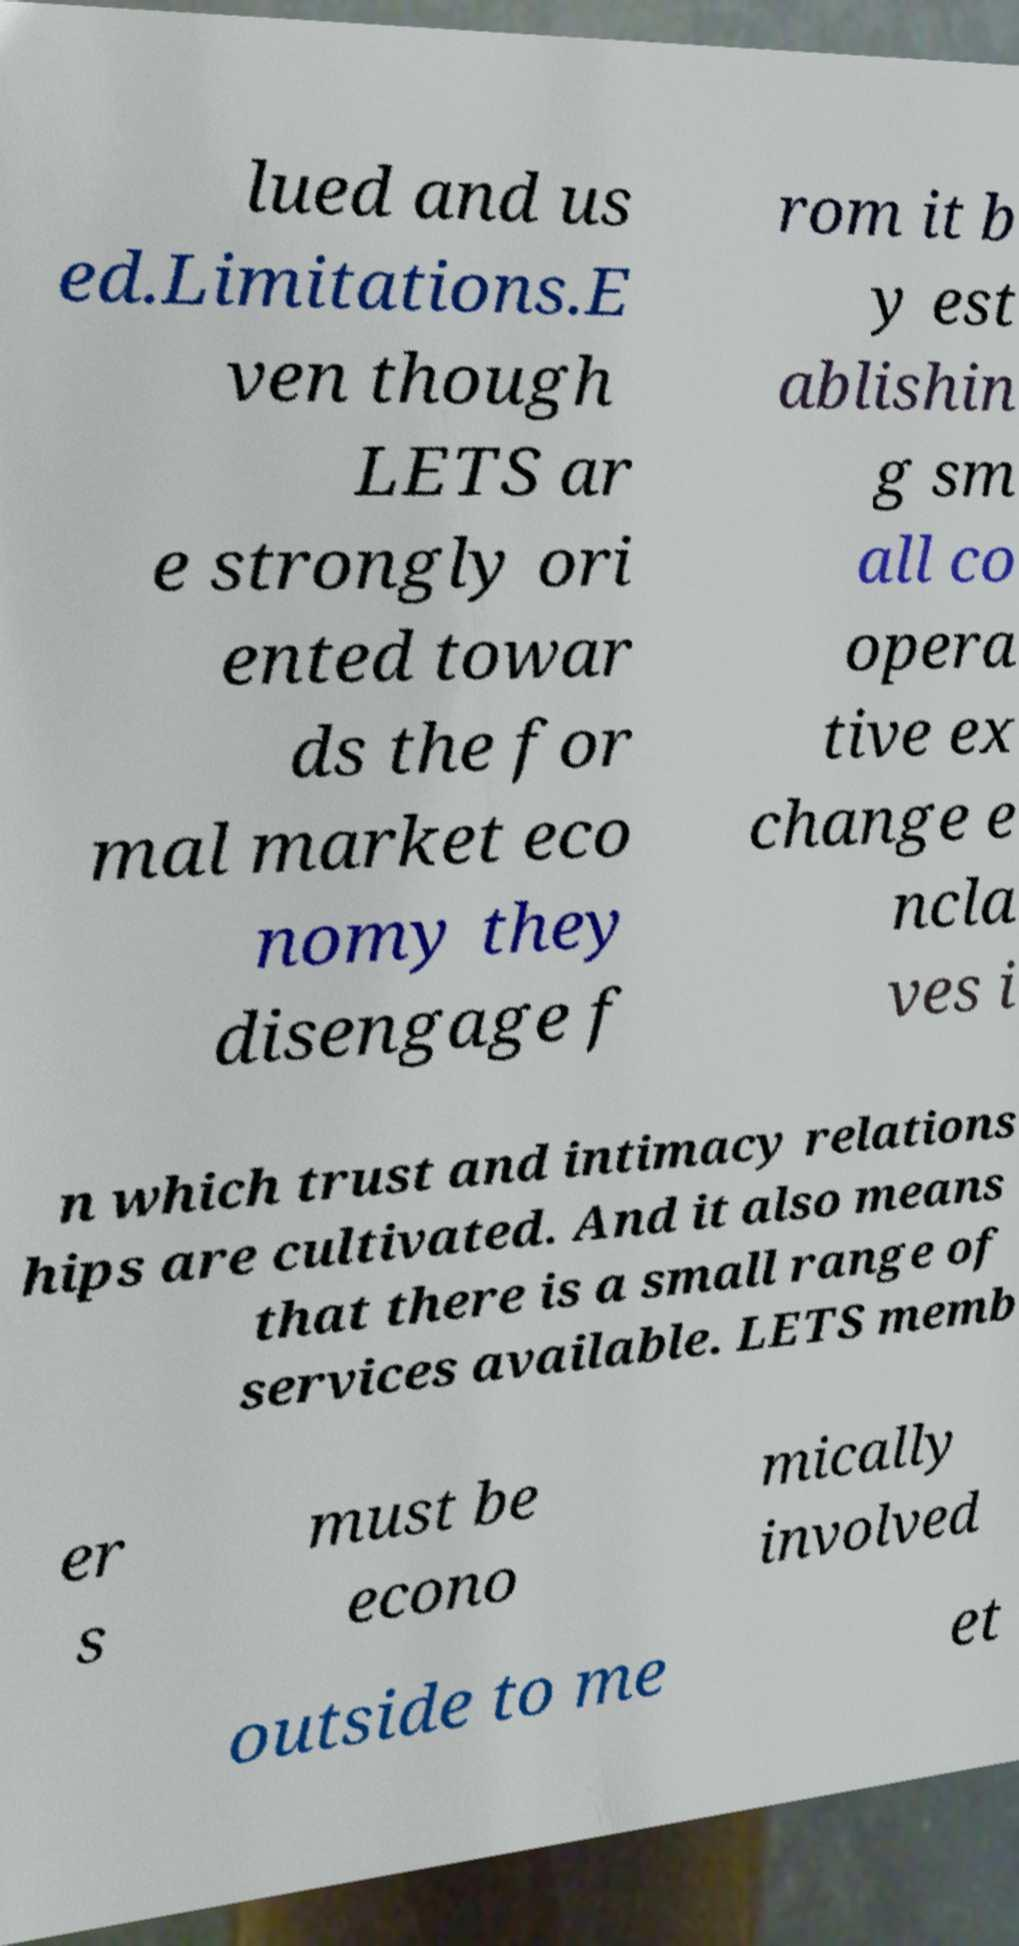What messages or text are displayed in this image? I need them in a readable, typed format. lued and us ed.Limitations.E ven though LETS ar e strongly ori ented towar ds the for mal market eco nomy they disengage f rom it b y est ablishin g sm all co opera tive ex change e ncla ves i n which trust and intimacy relations hips are cultivated. And it also means that there is a small range of services available. LETS memb er s must be econo mically involved outside to me et 